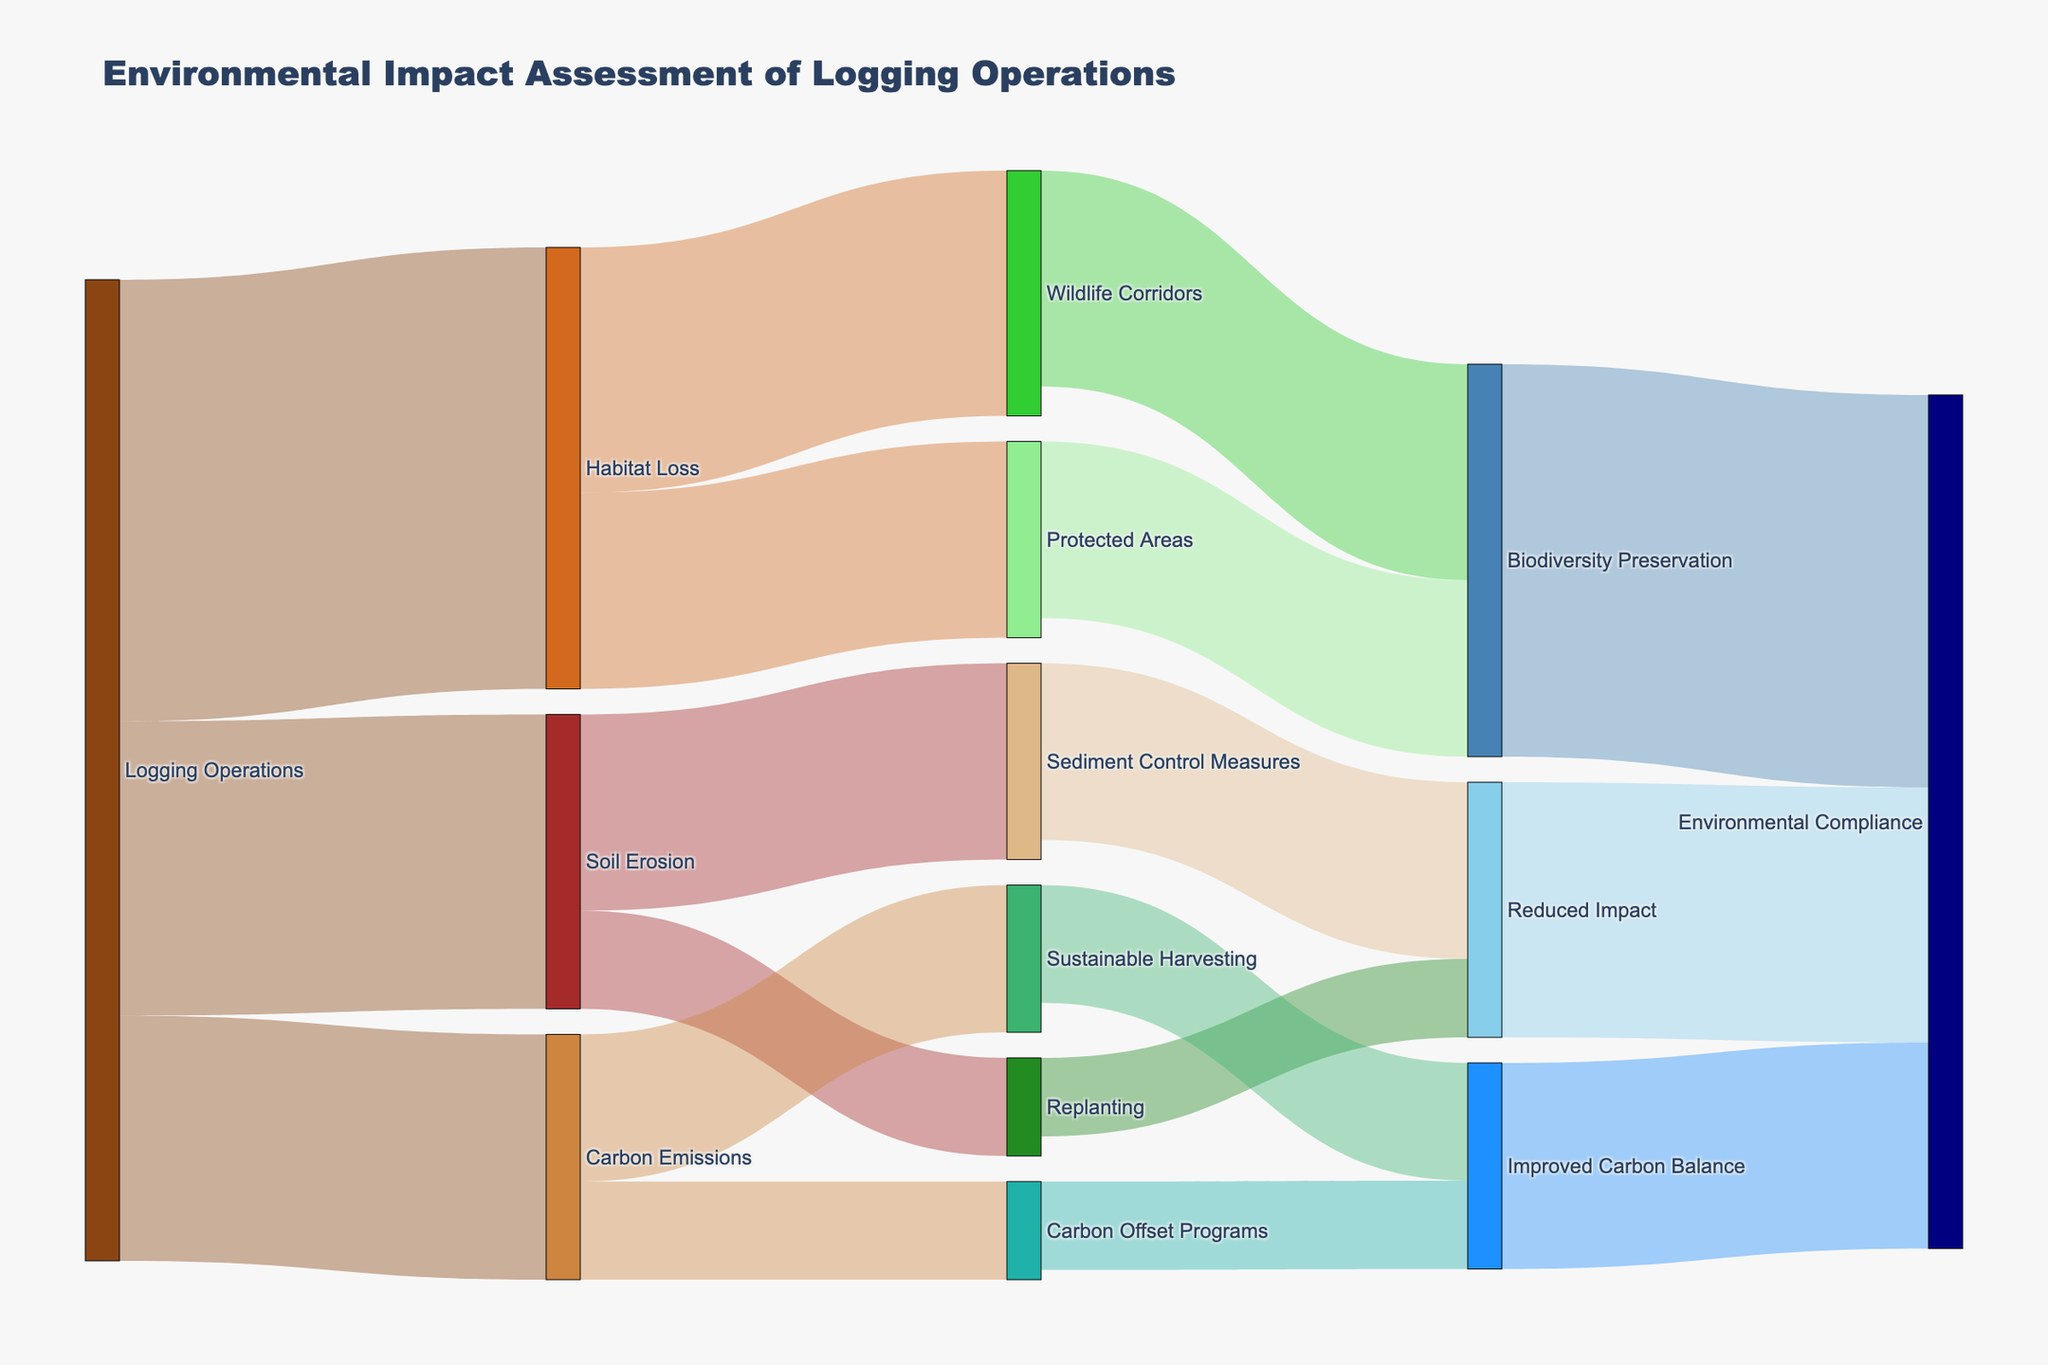what is the main environmental impact of logging operations according to the diagram? The diagram shows different environmental impacts like soil erosion, habitat loss, and carbon emissions. Habitat loss has the highest value (45) compared to soil erosion (30) and carbon emissions (25).
Answer: Habitat loss how much value is attributed to sediment control measures from soil erosion? The diagram indicates that there are values flowing from soil erosion to sediment control measures and replanting. Specifically, sediment control measures receive a flow value of 20 from soil erosion.
Answer: 20 compare the combined mitigation value achieved from wildlife corridors and protected areas regarding habitat loss The diagram indicates flows from habitat loss to wildlife corridors (25) and protected areas (20). Adding these values gives a combined mitigation value of 25 + 20 = 45 for habitat loss.
Answer: 45 how do carbon offset programs contribute to improved carbon balance? The diagram shows a flow from carbon offset programs to improved carbon balance with a value of 10, indicating that this is the amount of contribution made by carbon offset programs to improved carbon balance.
Answer: 10 what are the total values flowing from carbon emissions to their respective mitigation strategies? The carbon emissions node has two outgoing flows to sustainable harvesting (15) and carbon offset programs (10). Adding these values gives a total of 15 + 10 = 25.
Answer: 25 what is the combined value for environmental compliance from all contributing factors? Environmental compliance receives values from reduced impact (26), biodiversity preservation (40), and improved carbon balance (21). Summing these values gives 26 + 40 + 21 = 87.
Answer: 87 which has a greater value flowing to environmental compliance, biodiversity preservation or improved carbon balance? The flow values to environmental compliance are 40 from biodiversity preservation and 21 from improved carbon balance. Comparing these, biodiversity preservation has a higher value.
Answer: Biodiversity preservation how many mitigation strategies are associated with soil erosion? The diagram shows that soil erosion leads to two mitigation strategies: sediment control measures (20) and replanting (10).
Answer: two what flow value is associated with replanting towards reduced impact? From the diagram, the value flowing from replanting to reduced impact is indicated as 8.
Answer: 8 which is higher, the combined value of mitigation strategies for habitat loss or carbon emissions? Habitat loss mitigation involves flows to wildlife corridors (25) and protected areas (20), totaling 45. Carbon emissions mitigation involves flows to sustainable harvesting (15) and carbon offset programs (10), totaling 25. Comparing these, habitat loss has a higher combined value.
Answer: Habitat loss 